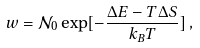<formula> <loc_0><loc_0><loc_500><loc_500>w = \mathcal { N } _ { 0 } \exp [ - \frac { \Delta E - T \Delta S } { k _ { B } T } ] \, ,</formula> 